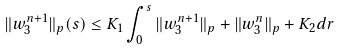Convert formula to latex. <formula><loc_0><loc_0><loc_500><loc_500>\| w _ { 3 } ^ { n + 1 } \| _ { p } ( s ) \leq K _ { 1 } \int _ { 0 } ^ { s } \| w _ { 3 } ^ { n + 1 } \| _ { p } + \| w _ { 3 } ^ { n } \| _ { p } + K _ { 2 } d r</formula> 